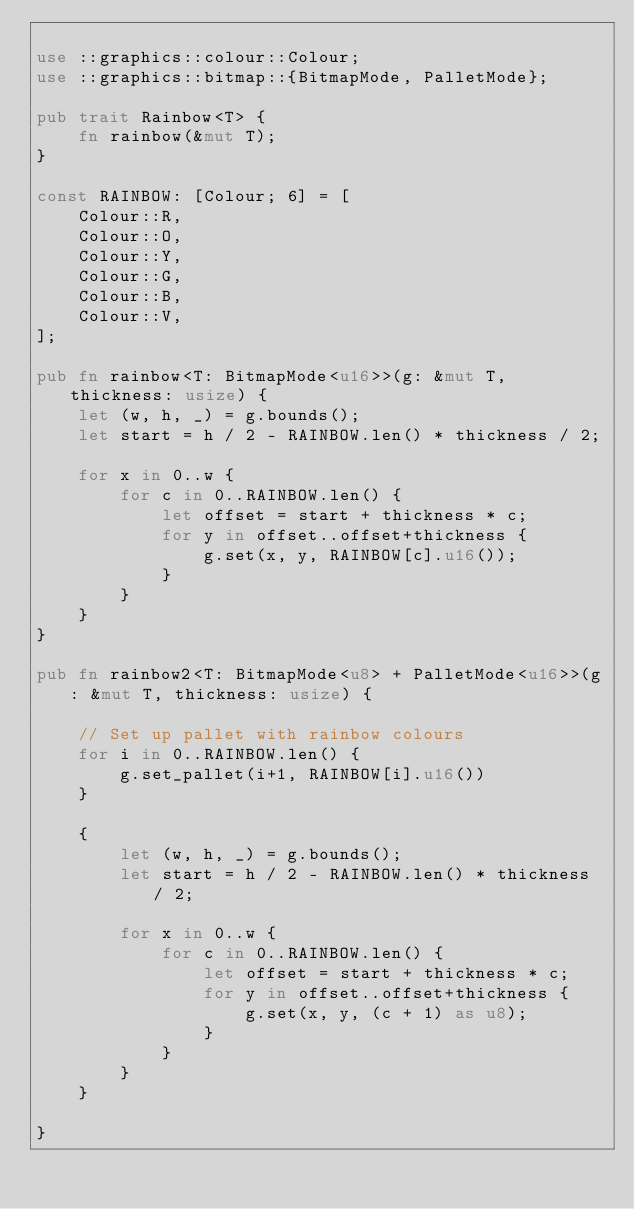Convert code to text. <code><loc_0><loc_0><loc_500><loc_500><_Rust_>
use ::graphics::colour::Colour;
use ::graphics::bitmap::{BitmapMode, PalletMode};

pub trait Rainbow<T> {
    fn rainbow(&mut T);
}

const RAINBOW: [Colour; 6] = [
    Colour::R,
    Colour::O,
    Colour::Y,
    Colour::G,
    Colour::B,
    Colour::V,
];

pub fn rainbow<T: BitmapMode<u16>>(g: &mut T, thickness: usize) {
    let (w, h, _) = g.bounds();
    let start = h / 2 - RAINBOW.len() * thickness / 2;

    for x in 0..w {
        for c in 0..RAINBOW.len() {
            let offset = start + thickness * c;
            for y in offset..offset+thickness {
                g.set(x, y, RAINBOW[c].u16());
            }
        }
    }
}

pub fn rainbow2<T: BitmapMode<u8> + PalletMode<u16>>(g: &mut T, thickness: usize) {

    // Set up pallet with rainbow colours
    for i in 0..RAINBOW.len() {
        g.set_pallet(i+1, RAINBOW[i].u16())
    }

    {
        let (w, h, _) = g.bounds();
        let start = h / 2 - RAINBOW.len() * thickness / 2;

        for x in 0..w {
            for c in 0..RAINBOW.len() {
                let offset = start + thickness * c;
                for y in offset..offset+thickness {
                    g.set(x, y, (c + 1) as u8);
                }
            }
        }
    }

}

</code> 